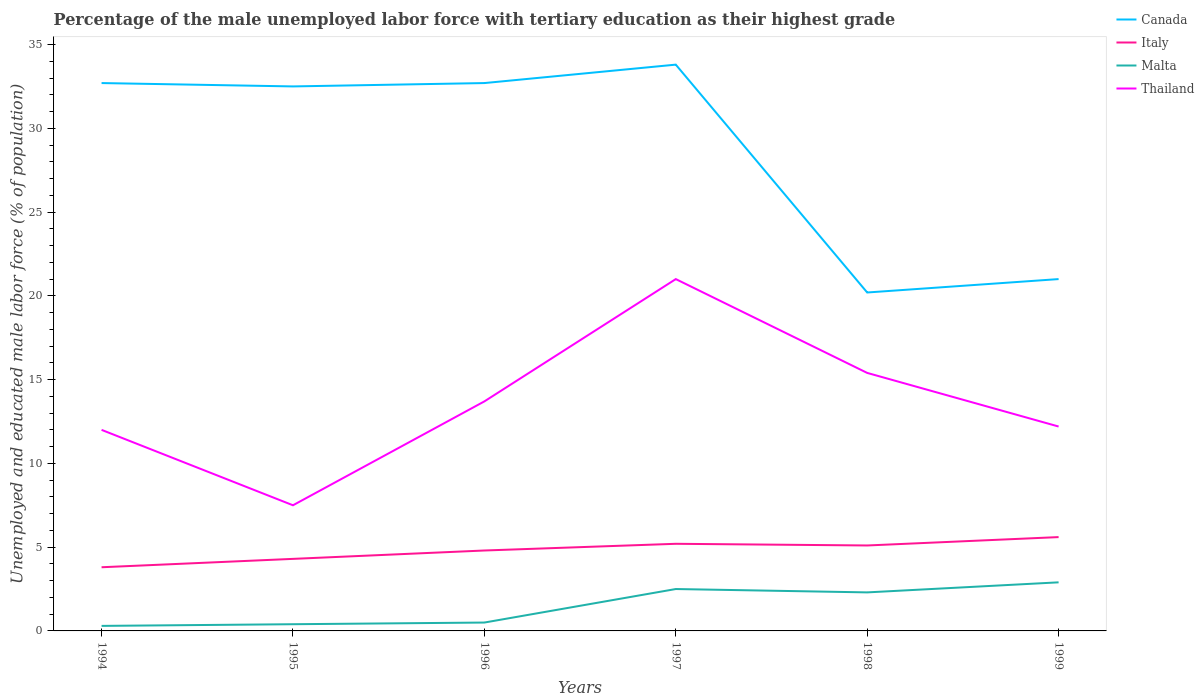Is the number of lines equal to the number of legend labels?
Your answer should be very brief. Yes. Across all years, what is the maximum percentage of the unemployed male labor force with tertiary education in Italy?
Give a very brief answer. 3.8. What is the total percentage of the unemployed male labor force with tertiary education in Malta in the graph?
Offer a terse response. -0.4. What is the difference between the highest and the second highest percentage of the unemployed male labor force with tertiary education in Thailand?
Offer a terse response. 13.5. What is the difference between two consecutive major ticks on the Y-axis?
Make the answer very short. 5. Are the values on the major ticks of Y-axis written in scientific E-notation?
Make the answer very short. No. Does the graph contain any zero values?
Keep it short and to the point. No. Where does the legend appear in the graph?
Provide a short and direct response. Top right. How are the legend labels stacked?
Your response must be concise. Vertical. What is the title of the graph?
Offer a very short reply. Percentage of the male unemployed labor force with tertiary education as their highest grade. What is the label or title of the X-axis?
Your response must be concise. Years. What is the label or title of the Y-axis?
Offer a terse response. Unemployed and educated male labor force (% of population). What is the Unemployed and educated male labor force (% of population) in Canada in 1994?
Make the answer very short. 32.7. What is the Unemployed and educated male labor force (% of population) of Italy in 1994?
Provide a short and direct response. 3.8. What is the Unemployed and educated male labor force (% of population) in Malta in 1994?
Ensure brevity in your answer.  0.3. What is the Unemployed and educated male labor force (% of population) in Thailand in 1994?
Your answer should be compact. 12. What is the Unemployed and educated male labor force (% of population) in Canada in 1995?
Offer a terse response. 32.5. What is the Unemployed and educated male labor force (% of population) in Italy in 1995?
Give a very brief answer. 4.3. What is the Unemployed and educated male labor force (% of population) of Malta in 1995?
Offer a very short reply. 0.4. What is the Unemployed and educated male labor force (% of population) in Thailand in 1995?
Offer a terse response. 7.5. What is the Unemployed and educated male labor force (% of population) of Canada in 1996?
Make the answer very short. 32.7. What is the Unemployed and educated male labor force (% of population) of Italy in 1996?
Ensure brevity in your answer.  4.8. What is the Unemployed and educated male labor force (% of population) in Thailand in 1996?
Keep it short and to the point. 13.7. What is the Unemployed and educated male labor force (% of population) of Canada in 1997?
Your response must be concise. 33.8. What is the Unemployed and educated male labor force (% of population) in Italy in 1997?
Offer a very short reply. 5.2. What is the Unemployed and educated male labor force (% of population) in Malta in 1997?
Keep it short and to the point. 2.5. What is the Unemployed and educated male labor force (% of population) in Canada in 1998?
Your answer should be very brief. 20.2. What is the Unemployed and educated male labor force (% of population) in Italy in 1998?
Keep it short and to the point. 5.1. What is the Unemployed and educated male labor force (% of population) in Malta in 1998?
Offer a very short reply. 2.3. What is the Unemployed and educated male labor force (% of population) of Thailand in 1998?
Give a very brief answer. 15.4. What is the Unemployed and educated male labor force (% of population) of Canada in 1999?
Provide a short and direct response. 21. What is the Unemployed and educated male labor force (% of population) of Italy in 1999?
Offer a very short reply. 5.6. What is the Unemployed and educated male labor force (% of population) in Malta in 1999?
Give a very brief answer. 2.9. What is the Unemployed and educated male labor force (% of population) in Thailand in 1999?
Offer a terse response. 12.2. Across all years, what is the maximum Unemployed and educated male labor force (% of population) of Canada?
Ensure brevity in your answer.  33.8. Across all years, what is the maximum Unemployed and educated male labor force (% of population) of Italy?
Your answer should be very brief. 5.6. Across all years, what is the maximum Unemployed and educated male labor force (% of population) of Malta?
Provide a short and direct response. 2.9. Across all years, what is the minimum Unemployed and educated male labor force (% of population) in Canada?
Your answer should be compact. 20.2. Across all years, what is the minimum Unemployed and educated male labor force (% of population) in Italy?
Your response must be concise. 3.8. Across all years, what is the minimum Unemployed and educated male labor force (% of population) in Malta?
Provide a short and direct response. 0.3. Across all years, what is the minimum Unemployed and educated male labor force (% of population) in Thailand?
Make the answer very short. 7.5. What is the total Unemployed and educated male labor force (% of population) of Canada in the graph?
Keep it short and to the point. 172.9. What is the total Unemployed and educated male labor force (% of population) of Italy in the graph?
Provide a short and direct response. 28.8. What is the total Unemployed and educated male labor force (% of population) in Thailand in the graph?
Provide a short and direct response. 81.8. What is the difference between the Unemployed and educated male labor force (% of population) in Italy in 1994 and that in 1995?
Keep it short and to the point. -0.5. What is the difference between the Unemployed and educated male labor force (% of population) of Malta in 1994 and that in 1995?
Provide a short and direct response. -0.1. What is the difference between the Unemployed and educated male labor force (% of population) of Canada in 1994 and that in 1996?
Ensure brevity in your answer.  0. What is the difference between the Unemployed and educated male labor force (% of population) in Italy in 1994 and that in 1996?
Your answer should be very brief. -1. What is the difference between the Unemployed and educated male labor force (% of population) in Thailand in 1994 and that in 1996?
Provide a short and direct response. -1.7. What is the difference between the Unemployed and educated male labor force (% of population) of Thailand in 1994 and that in 1997?
Your answer should be very brief. -9. What is the difference between the Unemployed and educated male labor force (% of population) in Canada in 1994 and that in 1998?
Provide a short and direct response. 12.5. What is the difference between the Unemployed and educated male labor force (% of population) in Malta in 1994 and that in 1999?
Provide a short and direct response. -2.6. What is the difference between the Unemployed and educated male labor force (% of population) of Malta in 1995 and that in 1996?
Give a very brief answer. -0.1. What is the difference between the Unemployed and educated male labor force (% of population) in Thailand in 1995 and that in 1996?
Offer a terse response. -6.2. What is the difference between the Unemployed and educated male labor force (% of population) of Italy in 1995 and that in 1997?
Offer a terse response. -0.9. What is the difference between the Unemployed and educated male labor force (% of population) in Thailand in 1995 and that in 1997?
Offer a terse response. -13.5. What is the difference between the Unemployed and educated male labor force (% of population) of Canada in 1995 and that in 1998?
Offer a terse response. 12.3. What is the difference between the Unemployed and educated male labor force (% of population) of Thailand in 1995 and that in 1998?
Offer a terse response. -7.9. What is the difference between the Unemployed and educated male labor force (% of population) in Canada in 1995 and that in 1999?
Offer a terse response. 11.5. What is the difference between the Unemployed and educated male labor force (% of population) in Malta in 1995 and that in 1999?
Offer a terse response. -2.5. What is the difference between the Unemployed and educated male labor force (% of population) of Thailand in 1996 and that in 1997?
Make the answer very short. -7.3. What is the difference between the Unemployed and educated male labor force (% of population) of Malta in 1996 and that in 1998?
Keep it short and to the point. -1.8. What is the difference between the Unemployed and educated male labor force (% of population) in Italy in 1996 and that in 1999?
Ensure brevity in your answer.  -0.8. What is the difference between the Unemployed and educated male labor force (% of population) in Malta in 1996 and that in 1999?
Provide a succinct answer. -2.4. What is the difference between the Unemployed and educated male labor force (% of population) of Canada in 1997 and that in 1998?
Your answer should be compact. 13.6. What is the difference between the Unemployed and educated male labor force (% of population) of Italy in 1997 and that in 1998?
Ensure brevity in your answer.  0.1. What is the difference between the Unemployed and educated male labor force (% of population) in Malta in 1997 and that in 1998?
Ensure brevity in your answer.  0.2. What is the difference between the Unemployed and educated male labor force (% of population) of Thailand in 1997 and that in 1998?
Give a very brief answer. 5.6. What is the difference between the Unemployed and educated male labor force (% of population) of Canada in 1997 and that in 1999?
Give a very brief answer. 12.8. What is the difference between the Unemployed and educated male labor force (% of population) in Italy in 1997 and that in 1999?
Your answer should be very brief. -0.4. What is the difference between the Unemployed and educated male labor force (% of population) in Canada in 1998 and that in 1999?
Ensure brevity in your answer.  -0.8. What is the difference between the Unemployed and educated male labor force (% of population) in Malta in 1998 and that in 1999?
Keep it short and to the point. -0.6. What is the difference between the Unemployed and educated male labor force (% of population) of Thailand in 1998 and that in 1999?
Your answer should be compact. 3.2. What is the difference between the Unemployed and educated male labor force (% of population) in Canada in 1994 and the Unemployed and educated male labor force (% of population) in Italy in 1995?
Your response must be concise. 28.4. What is the difference between the Unemployed and educated male labor force (% of population) in Canada in 1994 and the Unemployed and educated male labor force (% of population) in Malta in 1995?
Provide a succinct answer. 32.3. What is the difference between the Unemployed and educated male labor force (% of population) of Canada in 1994 and the Unemployed and educated male labor force (% of population) of Thailand in 1995?
Your answer should be very brief. 25.2. What is the difference between the Unemployed and educated male labor force (% of population) in Malta in 1994 and the Unemployed and educated male labor force (% of population) in Thailand in 1995?
Ensure brevity in your answer.  -7.2. What is the difference between the Unemployed and educated male labor force (% of population) of Canada in 1994 and the Unemployed and educated male labor force (% of population) of Italy in 1996?
Your answer should be compact. 27.9. What is the difference between the Unemployed and educated male labor force (% of population) of Canada in 1994 and the Unemployed and educated male labor force (% of population) of Malta in 1996?
Give a very brief answer. 32.2. What is the difference between the Unemployed and educated male labor force (% of population) of Canada in 1994 and the Unemployed and educated male labor force (% of population) of Thailand in 1996?
Your answer should be compact. 19. What is the difference between the Unemployed and educated male labor force (% of population) in Italy in 1994 and the Unemployed and educated male labor force (% of population) in Thailand in 1996?
Offer a terse response. -9.9. What is the difference between the Unemployed and educated male labor force (% of population) of Canada in 1994 and the Unemployed and educated male labor force (% of population) of Italy in 1997?
Your answer should be very brief. 27.5. What is the difference between the Unemployed and educated male labor force (% of population) of Canada in 1994 and the Unemployed and educated male labor force (% of population) of Malta in 1997?
Offer a terse response. 30.2. What is the difference between the Unemployed and educated male labor force (% of population) in Italy in 1994 and the Unemployed and educated male labor force (% of population) in Thailand in 1997?
Ensure brevity in your answer.  -17.2. What is the difference between the Unemployed and educated male labor force (% of population) of Malta in 1994 and the Unemployed and educated male labor force (% of population) of Thailand in 1997?
Make the answer very short. -20.7. What is the difference between the Unemployed and educated male labor force (% of population) of Canada in 1994 and the Unemployed and educated male labor force (% of population) of Italy in 1998?
Ensure brevity in your answer.  27.6. What is the difference between the Unemployed and educated male labor force (% of population) of Canada in 1994 and the Unemployed and educated male labor force (% of population) of Malta in 1998?
Make the answer very short. 30.4. What is the difference between the Unemployed and educated male labor force (% of population) of Canada in 1994 and the Unemployed and educated male labor force (% of population) of Thailand in 1998?
Your response must be concise. 17.3. What is the difference between the Unemployed and educated male labor force (% of population) of Malta in 1994 and the Unemployed and educated male labor force (% of population) of Thailand in 1998?
Ensure brevity in your answer.  -15.1. What is the difference between the Unemployed and educated male labor force (% of population) of Canada in 1994 and the Unemployed and educated male labor force (% of population) of Italy in 1999?
Your answer should be compact. 27.1. What is the difference between the Unemployed and educated male labor force (% of population) of Canada in 1994 and the Unemployed and educated male labor force (% of population) of Malta in 1999?
Keep it short and to the point. 29.8. What is the difference between the Unemployed and educated male labor force (% of population) of Canada in 1994 and the Unemployed and educated male labor force (% of population) of Thailand in 1999?
Your answer should be very brief. 20.5. What is the difference between the Unemployed and educated male labor force (% of population) of Italy in 1994 and the Unemployed and educated male labor force (% of population) of Thailand in 1999?
Provide a short and direct response. -8.4. What is the difference between the Unemployed and educated male labor force (% of population) of Canada in 1995 and the Unemployed and educated male labor force (% of population) of Italy in 1996?
Provide a short and direct response. 27.7. What is the difference between the Unemployed and educated male labor force (% of population) in Canada in 1995 and the Unemployed and educated male labor force (% of population) in Malta in 1996?
Offer a very short reply. 32. What is the difference between the Unemployed and educated male labor force (% of population) in Canada in 1995 and the Unemployed and educated male labor force (% of population) in Thailand in 1996?
Your answer should be compact. 18.8. What is the difference between the Unemployed and educated male labor force (% of population) in Italy in 1995 and the Unemployed and educated male labor force (% of population) in Malta in 1996?
Offer a terse response. 3.8. What is the difference between the Unemployed and educated male labor force (% of population) of Malta in 1995 and the Unemployed and educated male labor force (% of population) of Thailand in 1996?
Your response must be concise. -13.3. What is the difference between the Unemployed and educated male labor force (% of population) of Canada in 1995 and the Unemployed and educated male labor force (% of population) of Italy in 1997?
Keep it short and to the point. 27.3. What is the difference between the Unemployed and educated male labor force (% of population) of Italy in 1995 and the Unemployed and educated male labor force (% of population) of Thailand in 1997?
Provide a short and direct response. -16.7. What is the difference between the Unemployed and educated male labor force (% of population) of Malta in 1995 and the Unemployed and educated male labor force (% of population) of Thailand in 1997?
Provide a short and direct response. -20.6. What is the difference between the Unemployed and educated male labor force (% of population) in Canada in 1995 and the Unemployed and educated male labor force (% of population) in Italy in 1998?
Offer a very short reply. 27.4. What is the difference between the Unemployed and educated male labor force (% of population) in Canada in 1995 and the Unemployed and educated male labor force (% of population) in Malta in 1998?
Provide a succinct answer. 30.2. What is the difference between the Unemployed and educated male labor force (% of population) in Canada in 1995 and the Unemployed and educated male labor force (% of population) in Thailand in 1998?
Offer a terse response. 17.1. What is the difference between the Unemployed and educated male labor force (% of population) in Canada in 1995 and the Unemployed and educated male labor force (% of population) in Italy in 1999?
Your response must be concise. 26.9. What is the difference between the Unemployed and educated male labor force (% of population) of Canada in 1995 and the Unemployed and educated male labor force (% of population) of Malta in 1999?
Provide a short and direct response. 29.6. What is the difference between the Unemployed and educated male labor force (% of population) in Canada in 1995 and the Unemployed and educated male labor force (% of population) in Thailand in 1999?
Provide a short and direct response. 20.3. What is the difference between the Unemployed and educated male labor force (% of population) of Italy in 1995 and the Unemployed and educated male labor force (% of population) of Malta in 1999?
Provide a succinct answer. 1.4. What is the difference between the Unemployed and educated male labor force (% of population) of Italy in 1995 and the Unemployed and educated male labor force (% of population) of Thailand in 1999?
Offer a terse response. -7.9. What is the difference between the Unemployed and educated male labor force (% of population) in Malta in 1995 and the Unemployed and educated male labor force (% of population) in Thailand in 1999?
Your answer should be very brief. -11.8. What is the difference between the Unemployed and educated male labor force (% of population) of Canada in 1996 and the Unemployed and educated male labor force (% of population) of Malta in 1997?
Give a very brief answer. 30.2. What is the difference between the Unemployed and educated male labor force (% of population) in Canada in 1996 and the Unemployed and educated male labor force (% of population) in Thailand in 1997?
Give a very brief answer. 11.7. What is the difference between the Unemployed and educated male labor force (% of population) of Italy in 1996 and the Unemployed and educated male labor force (% of population) of Malta in 1997?
Give a very brief answer. 2.3. What is the difference between the Unemployed and educated male labor force (% of population) in Italy in 1996 and the Unemployed and educated male labor force (% of population) in Thailand in 1997?
Your answer should be very brief. -16.2. What is the difference between the Unemployed and educated male labor force (% of population) in Malta in 1996 and the Unemployed and educated male labor force (% of population) in Thailand in 1997?
Offer a terse response. -20.5. What is the difference between the Unemployed and educated male labor force (% of population) in Canada in 1996 and the Unemployed and educated male labor force (% of population) in Italy in 1998?
Your response must be concise. 27.6. What is the difference between the Unemployed and educated male labor force (% of population) of Canada in 1996 and the Unemployed and educated male labor force (% of population) of Malta in 1998?
Your answer should be very brief. 30.4. What is the difference between the Unemployed and educated male labor force (% of population) in Italy in 1996 and the Unemployed and educated male labor force (% of population) in Malta in 1998?
Ensure brevity in your answer.  2.5. What is the difference between the Unemployed and educated male labor force (% of population) of Italy in 1996 and the Unemployed and educated male labor force (% of population) of Thailand in 1998?
Make the answer very short. -10.6. What is the difference between the Unemployed and educated male labor force (% of population) in Malta in 1996 and the Unemployed and educated male labor force (% of population) in Thailand in 1998?
Offer a very short reply. -14.9. What is the difference between the Unemployed and educated male labor force (% of population) of Canada in 1996 and the Unemployed and educated male labor force (% of population) of Italy in 1999?
Your response must be concise. 27.1. What is the difference between the Unemployed and educated male labor force (% of population) in Canada in 1996 and the Unemployed and educated male labor force (% of population) in Malta in 1999?
Ensure brevity in your answer.  29.8. What is the difference between the Unemployed and educated male labor force (% of population) of Canada in 1996 and the Unemployed and educated male labor force (% of population) of Thailand in 1999?
Give a very brief answer. 20.5. What is the difference between the Unemployed and educated male labor force (% of population) of Canada in 1997 and the Unemployed and educated male labor force (% of population) of Italy in 1998?
Keep it short and to the point. 28.7. What is the difference between the Unemployed and educated male labor force (% of population) in Canada in 1997 and the Unemployed and educated male labor force (% of population) in Malta in 1998?
Offer a very short reply. 31.5. What is the difference between the Unemployed and educated male labor force (% of population) in Canada in 1997 and the Unemployed and educated male labor force (% of population) in Thailand in 1998?
Give a very brief answer. 18.4. What is the difference between the Unemployed and educated male labor force (% of population) in Canada in 1997 and the Unemployed and educated male labor force (% of population) in Italy in 1999?
Offer a very short reply. 28.2. What is the difference between the Unemployed and educated male labor force (% of population) in Canada in 1997 and the Unemployed and educated male labor force (% of population) in Malta in 1999?
Offer a terse response. 30.9. What is the difference between the Unemployed and educated male labor force (% of population) in Canada in 1997 and the Unemployed and educated male labor force (% of population) in Thailand in 1999?
Give a very brief answer. 21.6. What is the difference between the Unemployed and educated male labor force (% of population) in Italy in 1997 and the Unemployed and educated male labor force (% of population) in Malta in 1999?
Your answer should be very brief. 2.3. What is the difference between the Unemployed and educated male labor force (% of population) of Italy in 1997 and the Unemployed and educated male labor force (% of population) of Thailand in 1999?
Offer a terse response. -7. What is the difference between the Unemployed and educated male labor force (% of population) of Malta in 1997 and the Unemployed and educated male labor force (% of population) of Thailand in 1999?
Keep it short and to the point. -9.7. What is the average Unemployed and educated male labor force (% of population) of Canada per year?
Your answer should be compact. 28.82. What is the average Unemployed and educated male labor force (% of population) in Italy per year?
Offer a very short reply. 4.8. What is the average Unemployed and educated male labor force (% of population) of Malta per year?
Provide a short and direct response. 1.48. What is the average Unemployed and educated male labor force (% of population) of Thailand per year?
Your answer should be compact. 13.63. In the year 1994, what is the difference between the Unemployed and educated male labor force (% of population) of Canada and Unemployed and educated male labor force (% of population) of Italy?
Ensure brevity in your answer.  28.9. In the year 1994, what is the difference between the Unemployed and educated male labor force (% of population) of Canada and Unemployed and educated male labor force (% of population) of Malta?
Your answer should be compact. 32.4. In the year 1994, what is the difference between the Unemployed and educated male labor force (% of population) of Canada and Unemployed and educated male labor force (% of population) of Thailand?
Ensure brevity in your answer.  20.7. In the year 1994, what is the difference between the Unemployed and educated male labor force (% of population) in Malta and Unemployed and educated male labor force (% of population) in Thailand?
Make the answer very short. -11.7. In the year 1995, what is the difference between the Unemployed and educated male labor force (% of population) of Canada and Unemployed and educated male labor force (% of population) of Italy?
Your answer should be compact. 28.2. In the year 1995, what is the difference between the Unemployed and educated male labor force (% of population) of Canada and Unemployed and educated male labor force (% of population) of Malta?
Give a very brief answer. 32.1. In the year 1995, what is the difference between the Unemployed and educated male labor force (% of population) in Canada and Unemployed and educated male labor force (% of population) in Thailand?
Your response must be concise. 25. In the year 1995, what is the difference between the Unemployed and educated male labor force (% of population) in Malta and Unemployed and educated male labor force (% of population) in Thailand?
Make the answer very short. -7.1. In the year 1996, what is the difference between the Unemployed and educated male labor force (% of population) of Canada and Unemployed and educated male labor force (% of population) of Italy?
Your response must be concise. 27.9. In the year 1996, what is the difference between the Unemployed and educated male labor force (% of population) in Canada and Unemployed and educated male labor force (% of population) in Malta?
Offer a very short reply. 32.2. In the year 1996, what is the difference between the Unemployed and educated male labor force (% of population) in Canada and Unemployed and educated male labor force (% of population) in Thailand?
Give a very brief answer. 19. In the year 1996, what is the difference between the Unemployed and educated male labor force (% of population) in Italy and Unemployed and educated male labor force (% of population) in Thailand?
Ensure brevity in your answer.  -8.9. In the year 1996, what is the difference between the Unemployed and educated male labor force (% of population) of Malta and Unemployed and educated male labor force (% of population) of Thailand?
Offer a very short reply. -13.2. In the year 1997, what is the difference between the Unemployed and educated male labor force (% of population) of Canada and Unemployed and educated male labor force (% of population) of Italy?
Your response must be concise. 28.6. In the year 1997, what is the difference between the Unemployed and educated male labor force (% of population) of Canada and Unemployed and educated male labor force (% of population) of Malta?
Make the answer very short. 31.3. In the year 1997, what is the difference between the Unemployed and educated male labor force (% of population) of Italy and Unemployed and educated male labor force (% of population) of Thailand?
Ensure brevity in your answer.  -15.8. In the year 1997, what is the difference between the Unemployed and educated male labor force (% of population) in Malta and Unemployed and educated male labor force (% of population) in Thailand?
Offer a terse response. -18.5. In the year 1998, what is the difference between the Unemployed and educated male labor force (% of population) in Canada and Unemployed and educated male labor force (% of population) in Italy?
Offer a very short reply. 15.1. In the year 1999, what is the difference between the Unemployed and educated male labor force (% of population) of Canada and Unemployed and educated male labor force (% of population) of Malta?
Give a very brief answer. 18.1. In the year 1999, what is the difference between the Unemployed and educated male labor force (% of population) in Italy and Unemployed and educated male labor force (% of population) in Malta?
Your answer should be compact. 2.7. In the year 1999, what is the difference between the Unemployed and educated male labor force (% of population) of Malta and Unemployed and educated male labor force (% of population) of Thailand?
Offer a terse response. -9.3. What is the ratio of the Unemployed and educated male labor force (% of population) in Canada in 1994 to that in 1995?
Your answer should be very brief. 1.01. What is the ratio of the Unemployed and educated male labor force (% of population) of Italy in 1994 to that in 1995?
Your response must be concise. 0.88. What is the ratio of the Unemployed and educated male labor force (% of population) in Malta in 1994 to that in 1995?
Offer a terse response. 0.75. What is the ratio of the Unemployed and educated male labor force (% of population) in Canada in 1994 to that in 1996?
Ensure brevity in your answer.  1. What is the ratio of the Unemployed and educated male labor force (% of population) of Italy in 1994 to that in 1996?
Provide a short and direct response. 0.79. What is the ratio of the Unemployed and educated male labor force (% of population) of Thailand in 1994 to that in 1996?
Keep it short and to the point. 0.88. What is the ratio of the Unemployed and educated male labor force (% of population) in Canada in 1994 to that in 1997?
Provide a succinct answer. 0.97. What is the ratio of the Unemployed and educated male labor force (% of population) of Italy in 1994 to that in 1997?
Keep it short and to the point. 0.73. What is the ratio of the Unemployed and educated male labor force (% of population) of Malta in 1994 to that in 1997?
Offer a terse response. 0.12. What is the ratio of the Unemployed and educated male labor force (% of population) in Canada in 1994 to that in 1998?
Your response must be concise. 1.62. What is the ratio of the Unemployed and educated male labor force (% of population) of Italy in 1994 to that in 1998?
Give a very brief answer. 0.75. What is the ratio of the Unemployed and educated male labor force (% of population) in Malta in 1994 to that in 1998?
Ensure brevity in your answer.  0.13. What is the ratio of the Unemployed and educated male labor force (% of population) of Thailand in 1994 to that in 1998?
Your answer should be very brief. 0.78. What is the ratio of the Unemployed and educated male labor force (% of population) of Canada in 1994 to that in 1999?
Your answer should be very brief. 1.56. What is the ratio of the Unemployed and educated male labor force (% of population) of Italy in 1994 to that in 1999?
Provide a short and direct response. 0.68. What is the ratio of the Unemployed and educated male labor force (% of population) of Malta in 1994 to that in 1999?
Your answer should be very brief. 0.1. What is the ratio of the Unemployed and educated male labor force (% of population) of Thailand in 1994 to that in 1999?
Your response must be concise. 0.98. What is the ratio of the Unemployed and educated male labor force (% of population) in Italy in 1995 to that in 1996?
Provide a short and direct response. 0.9. What is the ratio of the Unemployed and educated male labor force (% of population) of Thailand in 1995 to that in 1996?
Provide a short and direct response. 0.55. What is the ratio of the Unemployed and educated male labor force (% of population) of Canada in 1995 to that in 1997?
Your answer should be very brief. 0.96. What is the ratio of the Unemployed and educated male labor force (% of population) of Italy in 1995 to that in 1997?
Keep it short and to the point. 0.83. What is the ratio of the Unemployed and educated male labor force (% of population) of Malta in 1995 to that in 1997?
Offer a very short reply. 0.16. What is the ratio of the Unemployed and educated male labor force (% of population) in Thailand in 1995 to that in 1997?
Give a very brief answer. 0.36. What is the ratio of the Unemployed and educated male labor force (% of population) of Canada in 1995 to that in 1998?
Give a very brief answer. 1.61. What is the ratio of the Unemployed and educated male labor force (% of population) in Italy in 1995 to that in 1998?
Ensure brevity in your answer.  0.84. What is the ratio of the Unemployed and educated male labor force (% of population) of Malta in 1995 to that in 1998?
Your answer should be very brief. 0.17. What is the ratio of the Unemployed and educated male labor force (% of population) in Thailand in 1995 to that in 1998?
Your answer should be very brief. 0.49. What is the ratio of the Unemployed and educated male labor force (% of population) of Canada in 1995 to that in 1999?
Keep it short and to the point. 1.55. What is the ratio of the Unemployed and educated male labor force (% of population) in Italy in 1995 to that in 1999?
Ensure brevity in your answer.  0.77. What is the ratio of the Unemployed and educated male labor force (% of population) in Malta in 1995 to that in 1999?
Provide a succinct answer. 0.14. What is the ratio of the Unemployed and educated male labor force (% of population) in Thailand in 1995 to that in 1999?
Provide a succinct answer. 0.61. What is the ratio of the Unemployed and educated male labor force (% of population) of Canada in 1996 to that in 1997?
Keep it short and to the point. 0.97. What is the ratio of the Unemployed and educated male labor force (% of population) of Italy in 1996 to that in 1997?
Your response must be concise. 0.92. What is the ratio of the Unemployed and educated male labor force (% of population) of Malta in 1996 to that in 1997?
Ensure brevity in your answer.  0.2. What is the ratio of the Unemployed and educated male labor force (% of population) in Thailand in 1996 to that in 1997?
Give a very brief answer. 0.65. What is the ratio of the Unemployed and educated male labor force (% of population) in Canada in 1996 to that in 1998?
Offer a terse response. 1.62. What is the ratio of the Unemployed and educated male labor force (% of population) of Malta in 1996 to that in 1998?
Provide a short and direct response. 0.22. What is the ratio of the Unemployed and educated male labor force (% of population) in Thailand in 1996 to that in 1998?
Provide a succinct answer. 0.89. What is the ratio of the Unemployed and educated male labor force (% of population) of Canada in 1996 to that in 1999?
Offer a terse response. 1.56. What is the ratio of the Unemployed and educated male labor force (% of population) of Italy in 1996 to that in 1999?
Offer a terse response. 0.86. What is the ratio of the Unemployed and educated male labor force (% of population) in Malta in 1996 to that in 1999?
Provide a short and direct response. 0.17. What is the ratio of the Unemployed and educated male labor force (% of population) of Thailand in 1996 to that in 1999?
Offer a terse response. 1.12. What is the ratio of the Unemployed and educated male labor force (% of population) in Canada in 1997 to that in 1998?
Ensure brevity in your answer.  1.67. What is the ratio of the Unemployed and educated male labor force (% of population) in Italy in 1997 to that in 1998?
Keep it short and to the point. 1.02. What is the ratio of the Unemployed and educated male labor force (% of population) of Malta in 1997 to that in 1998?
Your answer should be compact. 1.09. What is the ratio of the Unemployed and educated male labor force (% of population) in Thailand in 1997 to that in 1998?
Ensure brevity in your answer.  1.36. What is the ratio of the Unemployed and educated male labor force (% of population) in Canada in 1997 to that in 1999?
Offer a very short reply. 1.61. What is the ratio of the Unemployed and educated male labor force (% of population) of Italy in 1997 to that in 1999?
Keep it short and to the point. 0.93. What is the ratio of the Unemployed and educated male labor force (% of population) in Malta in 1997 to that in 1999?
Your answer should be compact. 0.86. What is the ratio of the Unemployed and educated male labor force (% of population) in Thailand in 1997 to that in 1999?
Your response must be concise. 1.72. What is the ratio of the Unemployed and educated male labor force (% of population) in Canada in 1998 to that in 1999?
Your answer should be compact. 0.96. What is the ratio of the Unemployed and educated male labor force (% of population) in Italy in 1998 to that in 1999?
Give a very brief answer. 0.91. What is the ratio of the Unemployed and educated male labor force (% of population) in Malta in 1998 to that in 1999?
Make the answer very short. 0.79. What is the ratio of the Unemployed and educated male labor force (% of population) of Thailand in 1998 to that in 1999?
Your answer should be very brief. 1.26. What is the difference between the highest and the second highest Unemployed and educated male labor force (% of population) in Malta?
Give a very brief answer. 0.4. What is the difference between the highest and the second highest Unemployed and educated male labor force (% of population) of Thailand?
Offer a terse response. 5.6. What is the difference between the highest and the lowest Unemployed and educated male labor force (% of population) in Malta?
Provide a short and direct response. 2.6. 